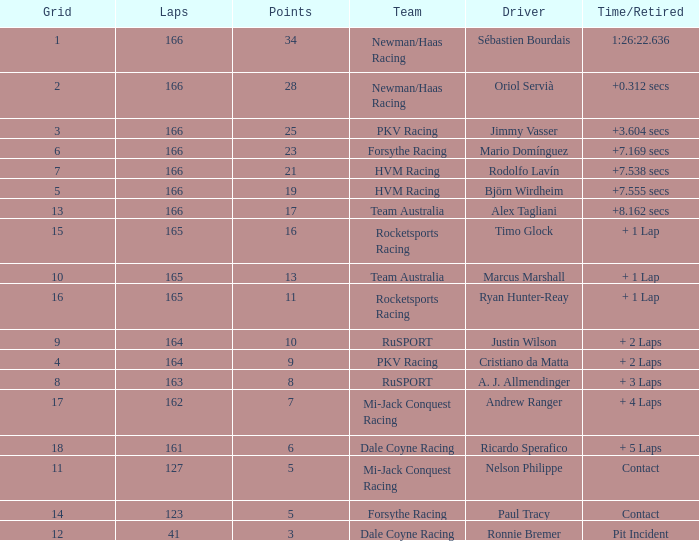What is the average points that the driver Ryan Hunter-Reay has? 11.0. 